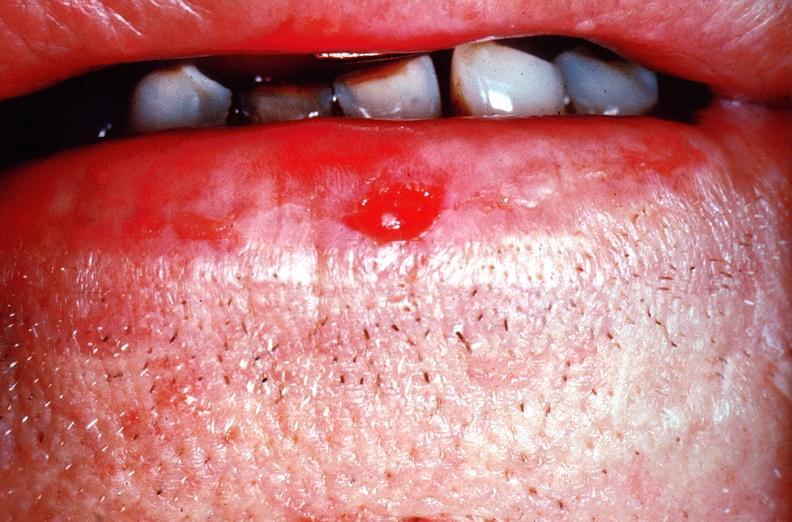what does this image show?
Answer the question using a single word or phrase. Squamous cell carcinoma of the lip 